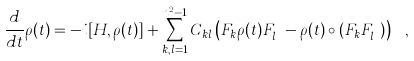Convert formula to latex. <formula><loc_0><loc_0><loc_500><loc_500>\frac { d } { d t } \rho ( t ) = - i [ H , \rho ( t ) ] + \sum ^ { n ^ { 2 } - 1 } _ { k , l = 1 } C _ { k l } \left ( F _ { k } \rho ( t ) F ^ { \dagger } _ { l } - \rho ( t ) \circ ( F _ { k } F ^ { \dagger } _ { l } ) \right ) \ ,</formula> 